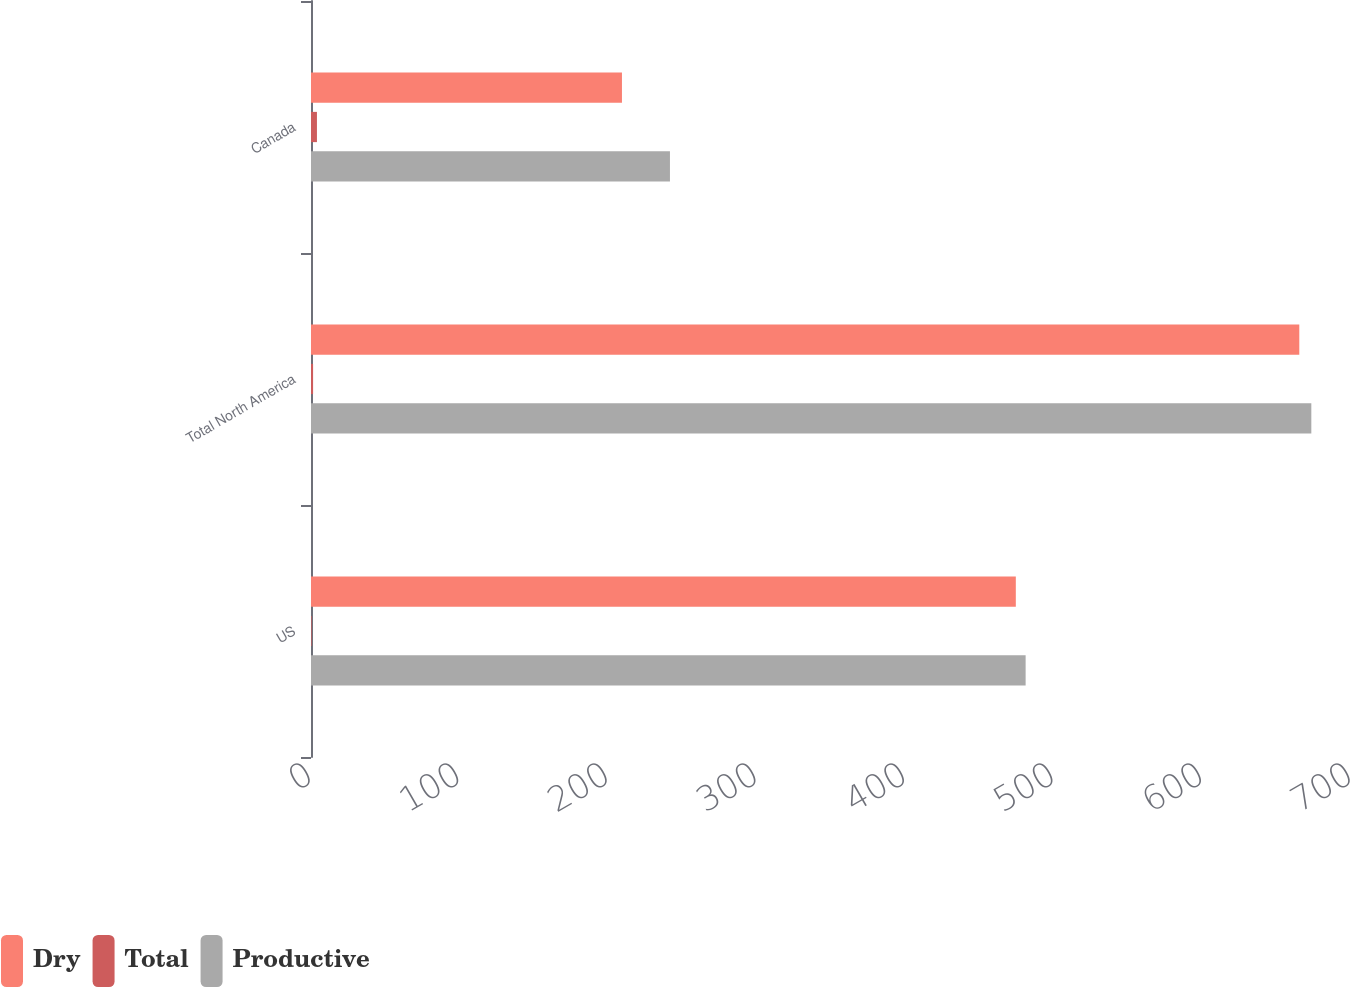Convert chart. <chart><loc_0><loc_0><loc_500><loc_500><stacked_bar_chart><ecel><fcel>US<fcel>Total North America<fcel>Canada<nl><fcel>Dry<fcel>474.4<fcel>665.2<fcel>209.3<nl><fcel>Total<fcel>0.4<fcel>1.4<fcel>4<nl><fcel>Productive<fcel>481<fcel>673.3<fcel>241.6<nl></chart> 